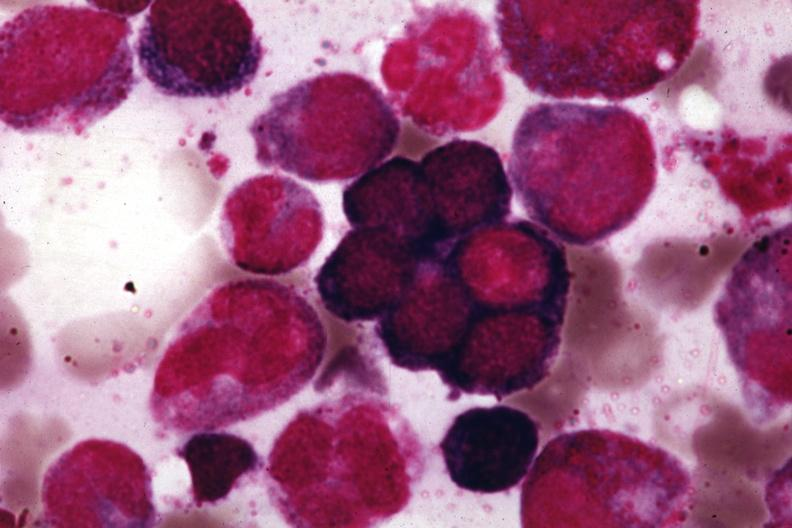does stillborn cord around neck show wrights?
Answer the question using a single word or phrase. No 